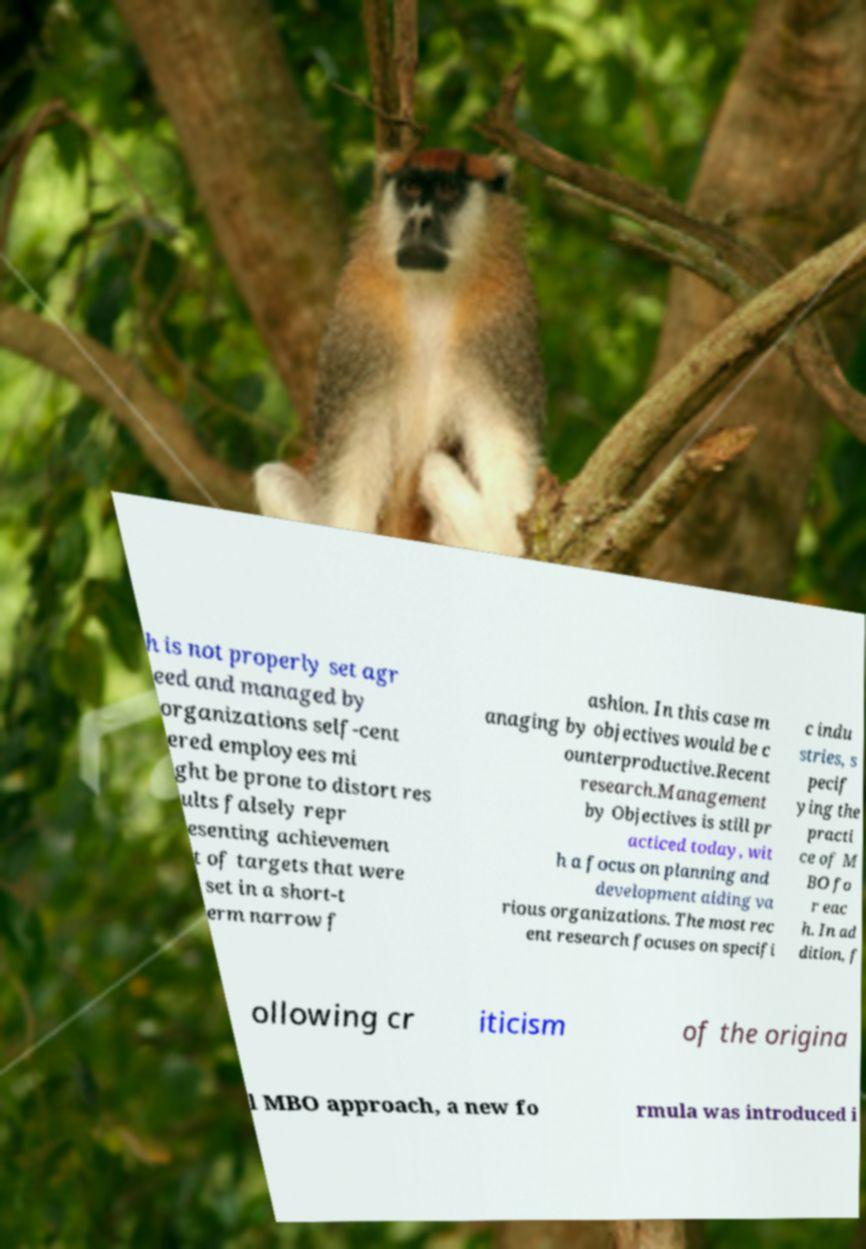What messages or text are displayed in this image? I need them in a readable, typed format. h is not properly set agr eed and managed by organizations self-cent ered employees mi ght be prone to distort res ults falsely repr esenting achievemen t of targets that were set in a short-t erm narrow f ashion. In this case m anaging by objectives would be c ounterproductive.Recent research.Management by Objectives is still pr acticed today, wit h a focus on planning and development aiding va rious organizations. The most rec ent research focuses on specifi c indu stries, s pecif ying the practi ce of M BO fo r eac h. In ad dition, f ollowing cr iticism of the origina l MBO approach, a new fo rmula was introduced i 